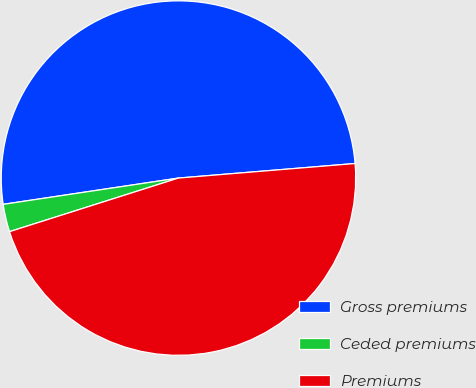Convert chart. <chart><loc_0><loc_0><loc_500><loc_500><pie_chart><fcel>Gross premiums<fcel>Ceded premiums<fcel>Premiums<nl><fcel>51.06%<fcel>2.52%<fcel>46.42%<nl></chart> 